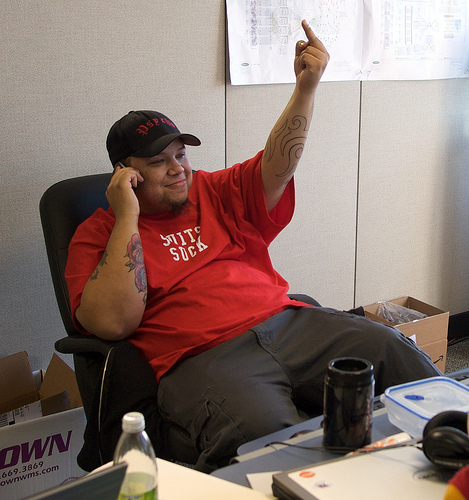<image>
Is the headphones on the man? No. The headphones is not positioned on the man. They may be near each other, but the headphones is not supported by or resting on top of the man. 